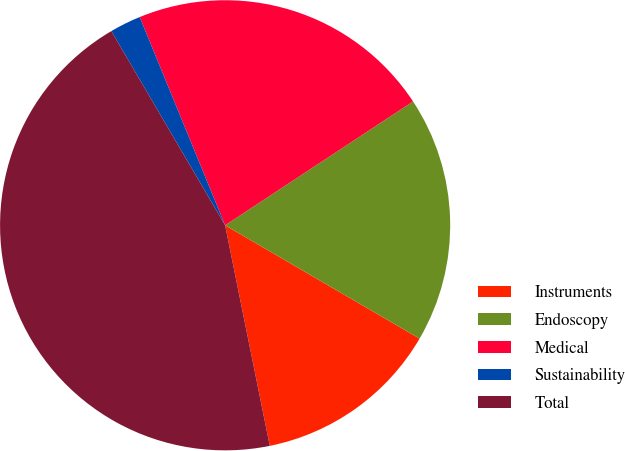Convert chart to OTSL. <chart><loc_0><loc_0><loc_500><loc_500><pie_chart><fcel>Instruments<fcel>Endoscopy<fcel>Medical<fcel>Sustainability<fcel>Total<nl><fcel>13.42%<fcel>17.67%<fcel>21.92%<fcel>2.24%<fcel>44.74%<nl></chart> 